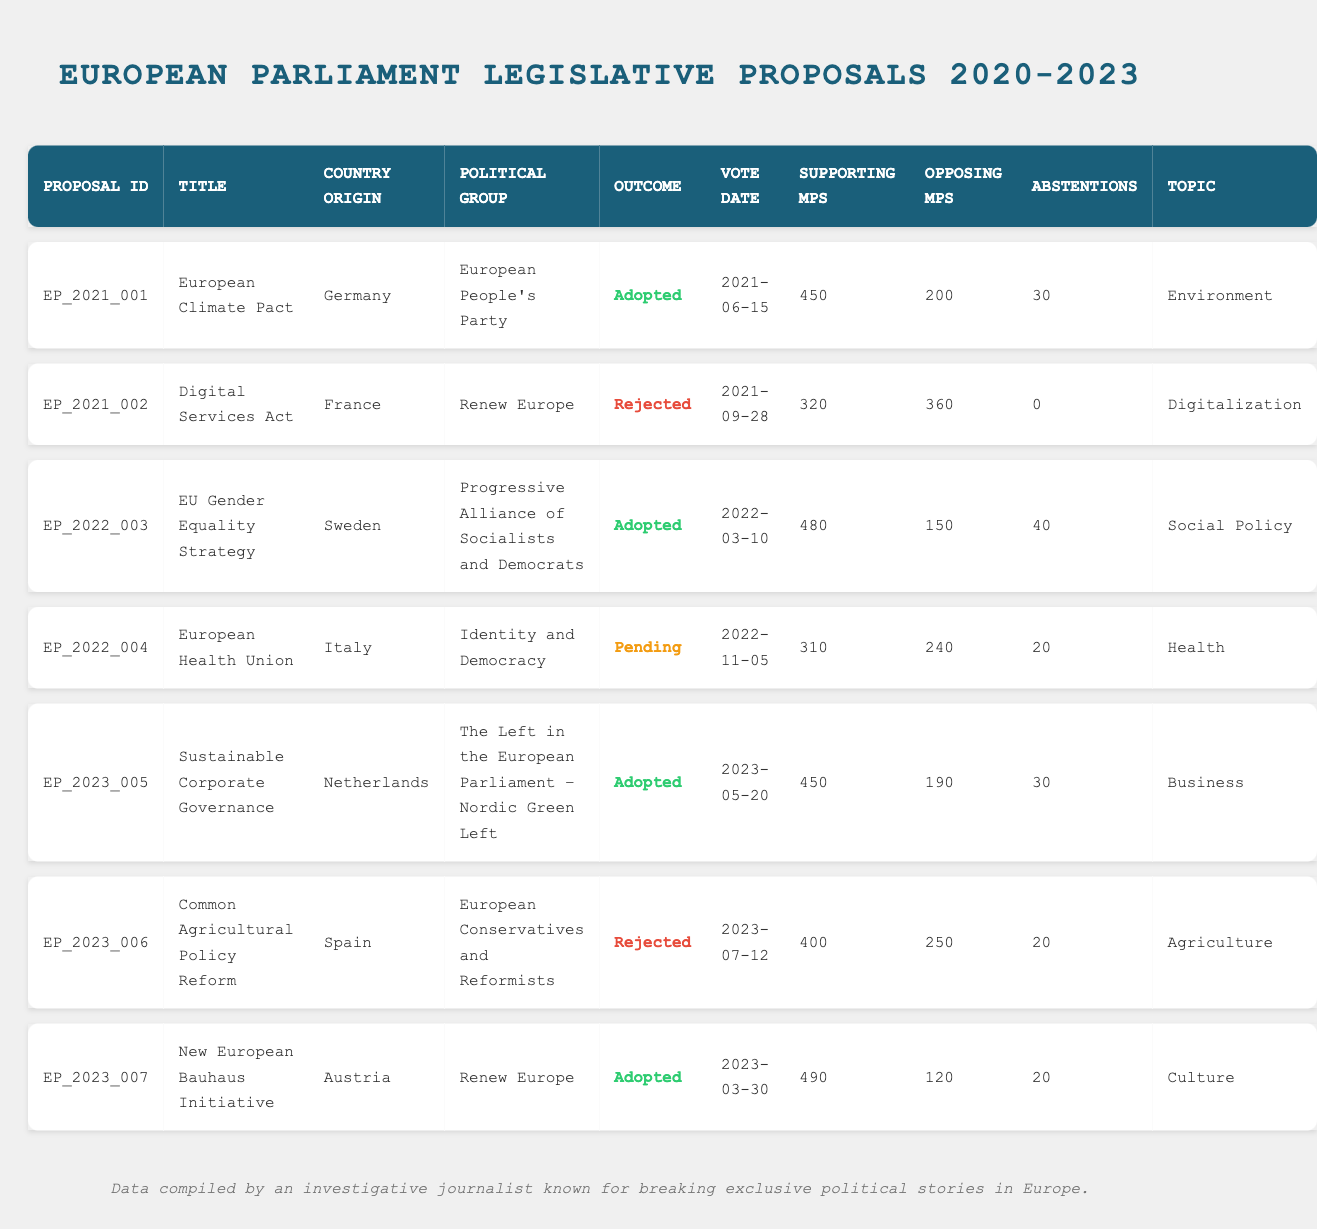What is the outcome of the European Climate Pact proposal? The proposal titled "European Climate Pact" has an outcome listed as "Adopted."
Answer: Adopted Which political group originated the Digital Services Act? The "Digital Services Act" originated from the "Renew Europe" political group.
Answer: Renew Europe How many supporting MPs were there for the EU Gender Equality Strategy? The EU Gender Equality Strategy had 480 supporting MPs according to the data.
Answer: 480 What was the vote date for the Common Agricultural Policy Reform? The vote date for the Common Agricultural Policy Reform is recorded as July 12, 2023.
Answer: 2023-07-12 How many proposals were adopted? There are four proposals marked as adopted: European Climate Pact, EU Gender Equality Strategy, Sustainable Corporate Governance, and New European Bauhaus Initiative.
Answer: 4 What is the total number of opposing MPs for all rejected proposals? The opposing MPs for the rejected proposals are 360 (Digital Services Act) + 250 (Common Agricultural Policy Reform) = 610; therefore, the total is 610 opposing MPs.
Answer: 610 Is the outcome of the European Health Union proposal currently decided? The European Health Union proposal is listed as "Pending," indicating that it has not yet been decided.
Answer: No Which proposal had the highest number of supporting MPs? The proposal with the highest number of supporting MPs is the EU Gender Equality Strategy, with 480 supporting MPs.
Answer: EU Gender Equality Strategy What percentage of MPs abstained from voting on the Sustainable Corporate Governance proposal? The number of abstentions for the Sustainable Corporate Governance proposal is 30 out of a total of 670 MPs (supporting + opposing + abstentions: 450 + 190 + 30 = 670). The percentage is (30/670) * 100 ≈ 4.48%.
Answer: Approximately 4.48% How does the number of opposing MPs for the Digital Services Act compare to the EU Gender Equality Strategy? The Digital Services Act had 360 opposing MPs, while the EU Gender Equality Strategy had 150 opposing MPs, showing that the Digital Services Act had more opposing MPs by 210.
Answer: More by 210 MPs 